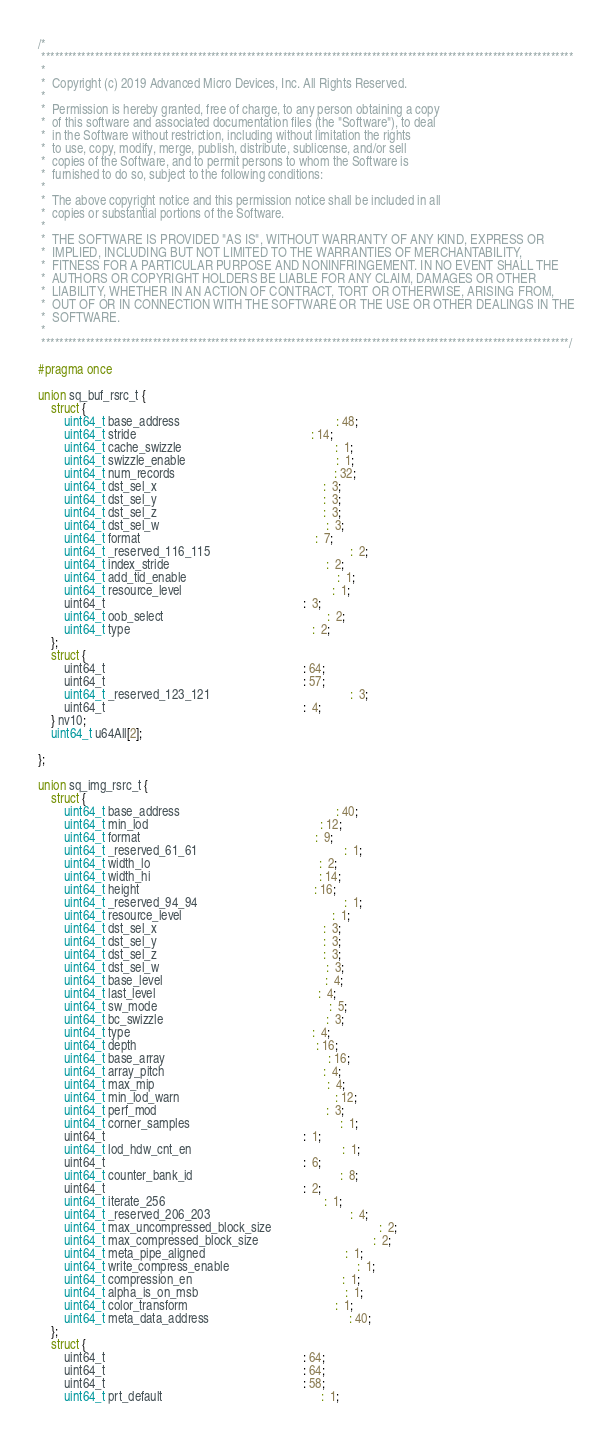Convert code to text. <code><loc_0><loc_0><loc_500><loc_500><_C_>/*
 ***********************************************************************************************************************
 *
 *  Copyright (c) 2019 Advanced Micro Devices, Inc. All Rights Reserved.
 *
 *  Permission is hereby granted, free of charge, to any person obtaining a copy
 *  of this software and associated documentation files (the "Software"), to deal
 *  in the Software without restriction, including without limitation the rights
 *  to use, copy, modify, merge, publish, distribute, sublicense, and/or sell
 *  copies of the Software, and to permit persons to whom the Software is
 *  furnished to do so, subject to the following conditions:
 *
 *  The above copyright notice and this permission notice shall be included in all
 *  copies or substantial portions of the Software.
 *
 *  THE SOFTWARE IS PROVIDED "AS IS", WITHOUT WARRANTY OF ANY KIND, EXPRESS OR
 *  IMPLIED, INCLUDING BUT NOT LIMITED TO THE WARRANTIES OF MERCHANTABILITY,
 *  FITNESS FOR A PARTICULAR PURPOSE AND NONINFRINGEMENT. IN NO EVENT SHALL THE
 *  AUTHORS OR COPYRIGHT HOLDERS BE LIABLE FOR ANY CLAIM, DAMAGES OR OTHER
 *  LIABILITY, WHETHER IN AN ACTION OF CONTRACT, TORT OR OTHERWISE, ARISING FROM,
 *  OUT OF OR IN CONNECTION WITH THE SOFTWARE OR THE USE OR OTHER DEALINGS IN THE
 *  SOFTWARE.
 *
 **********************************************************************************************************************/

#pragma once

union sq_buf_rsrc_t {
    struct {
        uint64_t base_address                                                 : 48;
        uint64_t stride                                                       : 14;
        uint64_t cache_swizzle                                                :  1;
        uint64_t swizzle_enable                                               :  1;
        uint64_t num_records                                                  : 32;
        uint64_t dst_sel_x                                                    :  3;
        uint64_t dst_sel_y                                                    :  3;
        uint64_t dst_sel_z                                                    :  3;
        uint64_t dst_sel_w                                                    :  3;
        uint64_t format                                                       :  7;
        uint64_t _reserved_116_115                                            :  2;
        uint64_t index_stride                                                 :  2;
        uint64_t add_tid_enable                                               :  1;
        uint64_t resource_level                                               :  1;
        uint64_t                                                              :  3;
        uint64_t oob_select                                                   :  2;
        uint64_t type                                                         :  2;
    };
    struct {
        uint64_t                                                              : 64;
        uint64_t                                                              : 57;
        uint64_t _reserved_123_121                                            :  3;
        uint64_t                                                              :  4;
    } nv10;
    uint64_t u64All[2];

};

union sq_img_rsrc_t {
    struct {
        uint64_t base_address                                                 : 40;
        uint64_t min_lod                                                      : 12;
        uint64_t format                                                       :  9;
        uint64_t _reserved_61_61                                              :  1;
        uint64_t width_lo                                                     :  2;
        uint64_t width_hi                                                     : 14;
        uint64_t height                                                       : 16;
        uint64_t _reserved_94_94                                              :  1;
        uint64_t resource_level                                               :  1;
        uint64_t dst_sel_x                                                    :  3;
        uint64_t dst_sel_y                                                    :  3;
        uint64_t dst_sel_z                                                    :  3;
        uint64_t dst_sel_w                                                    :  3;
        uint64_t base_level                                                   :  4;
        uint64_t last_level                                                   :  4;
        uint64_t sw_mode                                                      :  5;
        uint64_t bc_swizzle                                                   :  3;
        uint64_t type                                                         :  4;
        uint64_t depth                                                        : 16;
        uint64_t base_array                                                   : 16;
        uint64_t array_pitch                                                  :  4;
        uint64_t max_mip                                                      :  4;
        uint64_t min_lod_warn                                                 : 12;
        uint64_t perf_mod                                                     :  3;
        uint64_t corner_samples                                               :  1;
        uint64_t                                                              :  1;
        uint64_t lod_hdw_cnt_en                                               :  1;
        uint64_t                                                              :  6;
        uint64_t counter_bank_id                                              :  8;
        uint64_t                                                              :  2;
        uint64_t iterate_256                                                  :  1;
        uint64_t _reserved_206_203                                            :  4;
        uint64_t max_uncompressed_block_size                                  :  2;
        uint64_t max_compressed_block_size                                    :  2;
        uint64_t meta_pipe_aligned                                            :  1;
        uint64_t write_compress_enable                                        :  1;
        uint64_t compression_en                                               :  1;
        uint64_t alpha_is_on_msb                                              :  1;
        uint64_t color_transform                                              :  1;
        uint64_t meta_data_address                                            : 40;
    };
    struct {
        uint64_t                                                              : 64;
        uint64_t                                                              : 64;
        uint64_t                                                              : 58;
        uint64_t prt_default                                                  :  1;</code> 